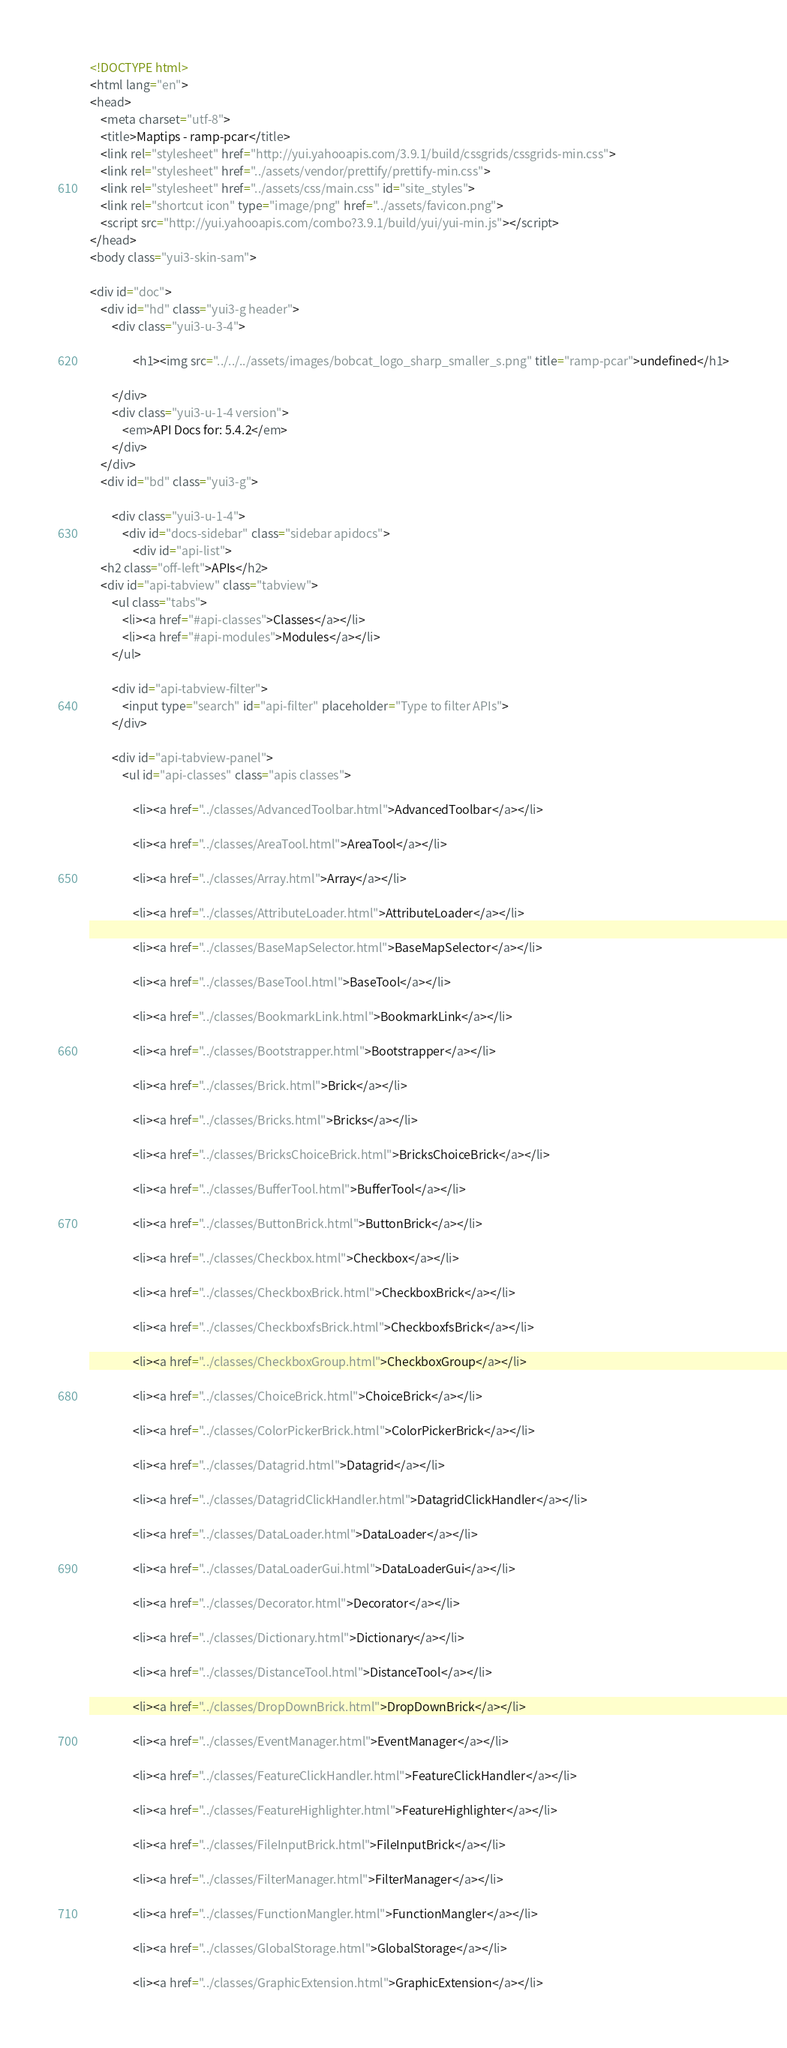<code> <loc_0><loc_0><loc_500><loc_500><_HTML_><!DOCTYPE html>
<html lang="en">
<head>
    <meta charset="utf-8">
    <title>Maptips - ramp-pcar</title>
    <link rel="stylesheet" href="http://yui.yahooapis.com/3.9.1/build/cssgrids/cssgrids-min.css">
    <link rel="stylesheet" href="../assets/vendor/prettify/prettify-min.css">
    <link rel="stylesheet" href="../assets/css/main.css" id="site_styles">
    <link rel="shortcut icon" type="image/png" href="../assets/favicon.png">
    <script src="http://yui.yahooapis.com/combo?3.9.1/build/yui/yui-min.js"></script>
</head>
<body class="yui3-skin-sam">

<div id="doc">
    <div id="hd" class="yui3-g header">
        <div class="yui3-u-3-4">
            
                <h1><img src="../../../assets/images/bobcat_logo_sharp_smaller_s.png" title="ramp-pcar">undefined</h1>
            
        </div>
        <div class="yui3-u-1-4 version">
            <em>API Docs for: 5.4.2</em>
        </div>
    </div>
    <div id="bd" class="yui3-g">

        <div class="yui3-u-1-4">
            <div id="docs-sidebar" class="sidebar apidocs">
                <div id="api-list">
    <h2 class="off-left">APIs</h2>
    <div id="api-tabview" class="tabview">
        <ul class="tabs">
            <li><a href="#api-classes">Classes</a></li>
            <li><a href="#api-modules">Modules</a></li>
        </ul>

        <div id="api-tabview-filter">
            <input type="search" id="api-filter" placeholder="Type to filter APIs">
        </div>

        <div id="api-tabview-panel">
            <ul id="api-classes" class="apis classes">
            
                <li><a href="../classes/AdvancedToolbar.html">AdvancedToolbar</a></li>
            
                <li><a href="../classes/AreaTool.html">AreaTool</a></li>
            
                <li><a href="../classes/Array.html">Array</a></li>
            
                <li><a href="../classes/AttributeLoader.html">AttributeLoader</a></li>
            
                <li><a href="../classes/BaseMapSelector.html">BaseMapSelector</a></li>
            
                <li><a href="../classes/BaseTool.html">BaseTool</a></li>
            
                <li><a href="../classes/BookmarkLink.html">BookmarkLink</a></li>
            
                <li><a href="../classes/Bootstrapper.html">Bootstrapper</a></li>
            
                <li><a href="../classes/Brick.html">Brick</a></li>
            
                <li><a href="../classes/Bricks.html">Bricks</a></li>
            
                <li><a href="../classes/BricksChoiceBrick.html">BricksChoiceBrick</a></li>
            
                <li><a href="../classes/BufferTool.html">BufferTool</a></li>
            
                <li><a href="../classes/ButtonBrick.html">ButtonBrick</a></li>
            
                <li><a href="../classes/Checkbox.html">Checkbox</a></li>
            
                <li><a href="../classes/CheckboxBrick.html">CheckboxBrick</a></li>
            
                <li><a href="../classes/CheckboxfsBrick.html">CheckboxfsBrick</a></li>
            
                <li><a href="../classes/CheckboxGroup.html">CheckboxGroup</a></li>
            
                <li><a href="../classes/ChoiceBrick.html">ChoiceBrick</a></li>
            
                <li><a href="../classes/ColorPickerBrick.html">ColorPickerBrick</a></li>
            
                <li><a href="../classes/Datagrid.html">Datagrid</a></li>
            
                <li><a href="../classes/DatagridClickHandler.html">DatagridClickHandler</a></li>
            
                <li><a href="../classes/DataLoader.html">DataLoader</a></li>
            
                <li><a href="../classes/DataLoaderGui.html">DataLoaderGui</a></li>
            
                <li><a href="../classes/Decorator.html">Decorator</a></li>
            
                <li><a href="../classes/Dictionary.html">Dictionary</a></li>
            
                <li><a href="../classes/DistanceTool.html">DistanceTool</a></li>
            
                <li><a href="../classes/DropDownBrick.html">DropDownBrick</a></li>
            
                <li><a href="../classes/EventManager.html">EventManager</a></li>
            
                <li><a href="../classes/FeatureClickHandler.html">FeatureClickHandler</a></li>
            
                <li><a href="../classes/FeatureHighlighter.html">FeatureHighlighter</a></li>
            
                <li><a href="../classes/FileInputBrick.html">FileInputBrick</a></li>
            
                <li><a href="../classes/FilterManager.html">FilterManager</a></li>
            
                <li><a href="../classes/FunctionMangler.html">FunctionMangler</a></li>
            
                <li><a href="../classes/GlobalStorage.html">GlobalStorage</a></li>
            
                <li><a href="../classes/GraphicExtension.html">GraphicExtension</a></li></code> 